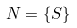Convert formula to latex. <formula><loc_0><loc_0><loc_500><loc_500>N = \{ S \}</formula> 